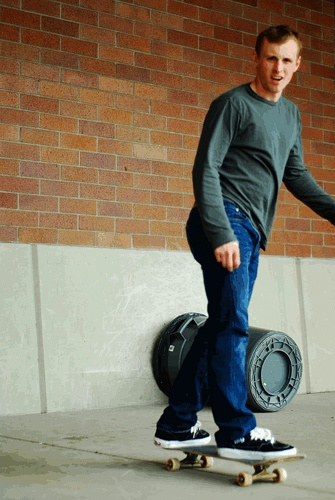Describe the objects in this image and their specific colors. I can see people in maroon, black, teal, and blue tones and skateboard in maroon, black, tan, olive, and gray tones in this image. 